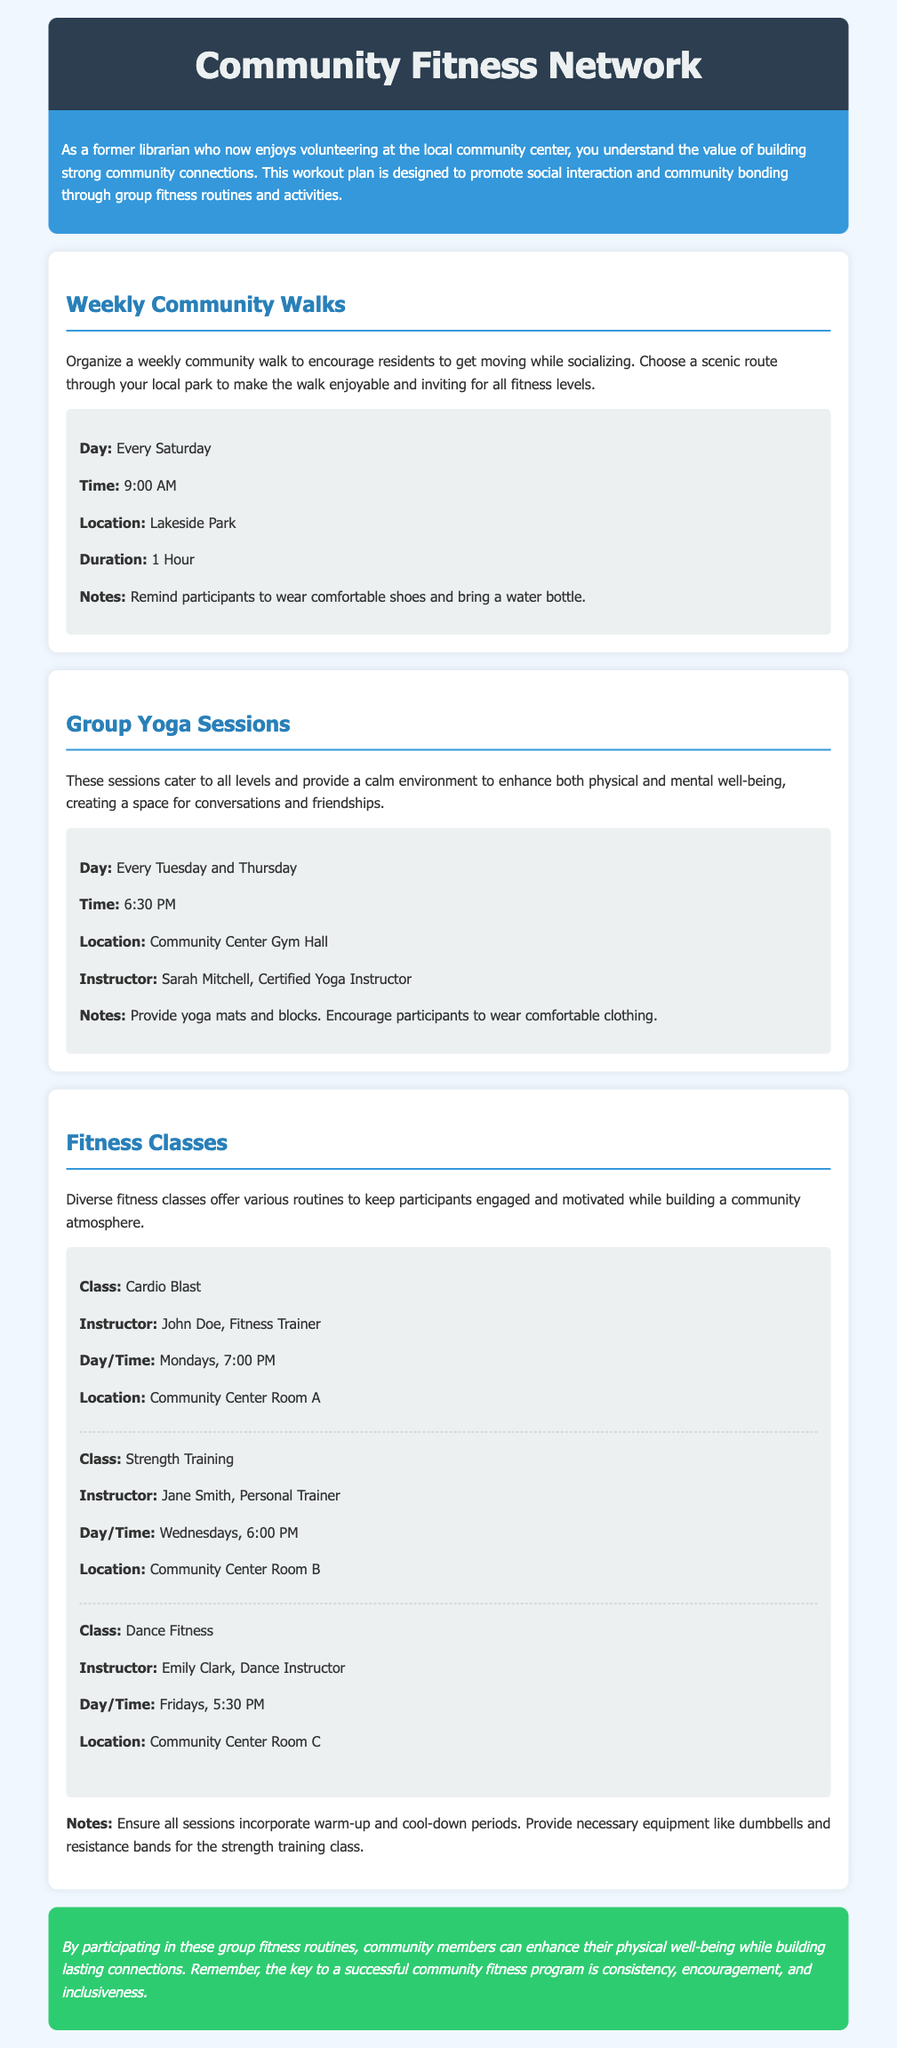What day are community walks held? The document specifies that community walks are organized every Saturday.
Answer: Every Saturday What time do the group yoga sessions start? According to the document, group yoga sessions start at 6:30 PM.
Answer: 6:30 PM Where are the strength training classes conducted? The document states that strength training classes take place in Community Center Room B.
Answer: Community Center Room B Who instructs the Cardio Blast class? The document lists John Doe as the instructor for the Cardio Blast class.
Answer: John Doe How long is the weekly community walk? The details indicate that the duration of the weekly community walk is 1 hour.
Answer: 1 Hour How many times a week are group yoga sessions held? The document mentions that group yoga sessions are held twice a week, on Tuesday and Thursday.
Answer: Twice a week What is the location for dance fitness classes? The document notes that dance fitness classes are held in Community Center Room C.
Answer: Community Center Room C What should participants bring to the community walk? The document advises participants to bring a water bottle to the community walk.
Answer: Water bottle What key aspect is emphasized for a successful community fitness program? The document highlights that consistency is a key aspect for a successful community fitness program.
Answer: Consistency 